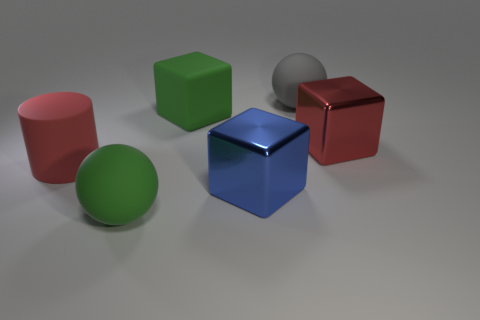What material is the thing that is in front of the large metal cube that is in front of the large red matte object made of?
Give a very brief answer. Rubber. Are there any metal objects that have the same shape as the big red rubber thing?
Your response must be concise. No. There is a matte cube that is the same size as the red cylinder; what is its color?
Offer a terse response. Green. How many objects are either metal objects that are in front of the large red rubber thing or big cubes that are right of the big gray rubber thing?
Keep it short and to the point. 2. What number of objects are tiny purple metal cubes or large green things?
Ensure brevity in your answer.  2. What number of large blue cubes have the same material as the big blue object?
Your answer should be very brief. 0. There is a cylinder that is made of the same material as the big green block; what is its color?
Provide a succinct answer. Red. There is a large matte thing in front of the blue thing; is its color the same as the big rubber block?
Your answer should be very brief. Yes. What is the cube right of the blue object made of?
Your response must be concise. Metal. Is the number of large red things left of the big green rubber ball the same as the number of red matte things?
Provide a short and direct response. Yes. 